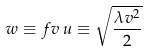Convert formula to latex. <formula><loc_0><loc_0><loc_500><loc_500>w \equiv f v \, u \equiv \sqrt { \frac { \lambda v ^ { 2 } } { 2 } }</formula> 